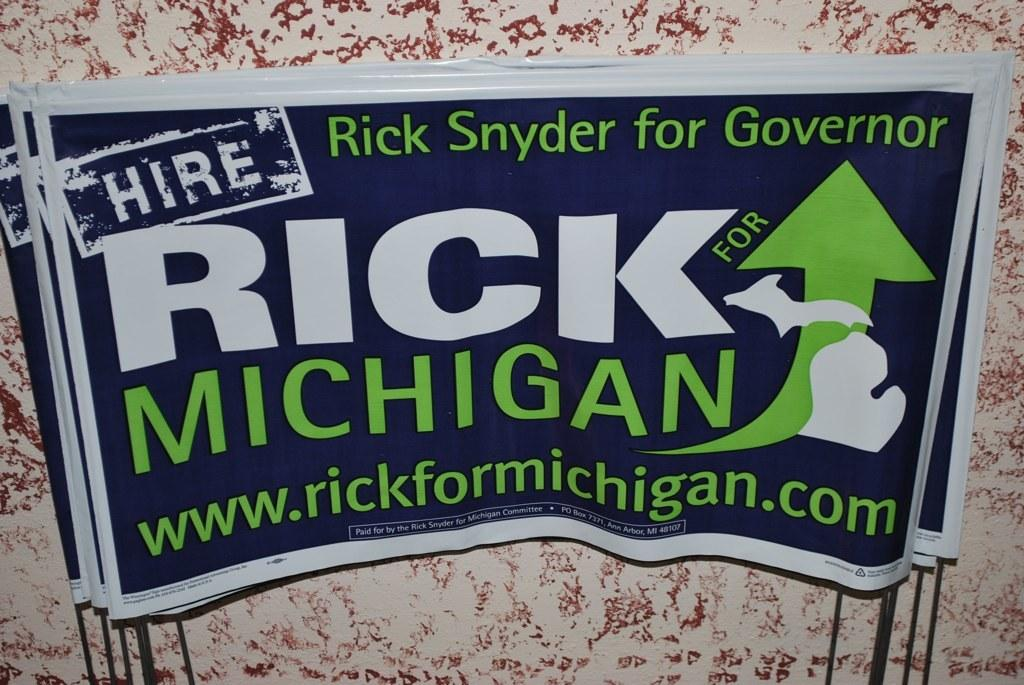Provide a one-sentence caption for the provided image. A sticker advertising Rick Synder for governer of Michigan. 